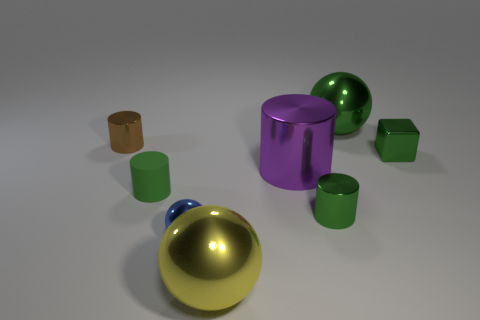How does the lighting in the scene affect the appearance of the objects? The overhead lighting produces soft shadows and enhances the luster of the reflective surfaces, giving the objects a three-dimensional quality and making the scene appear more dynamic. 